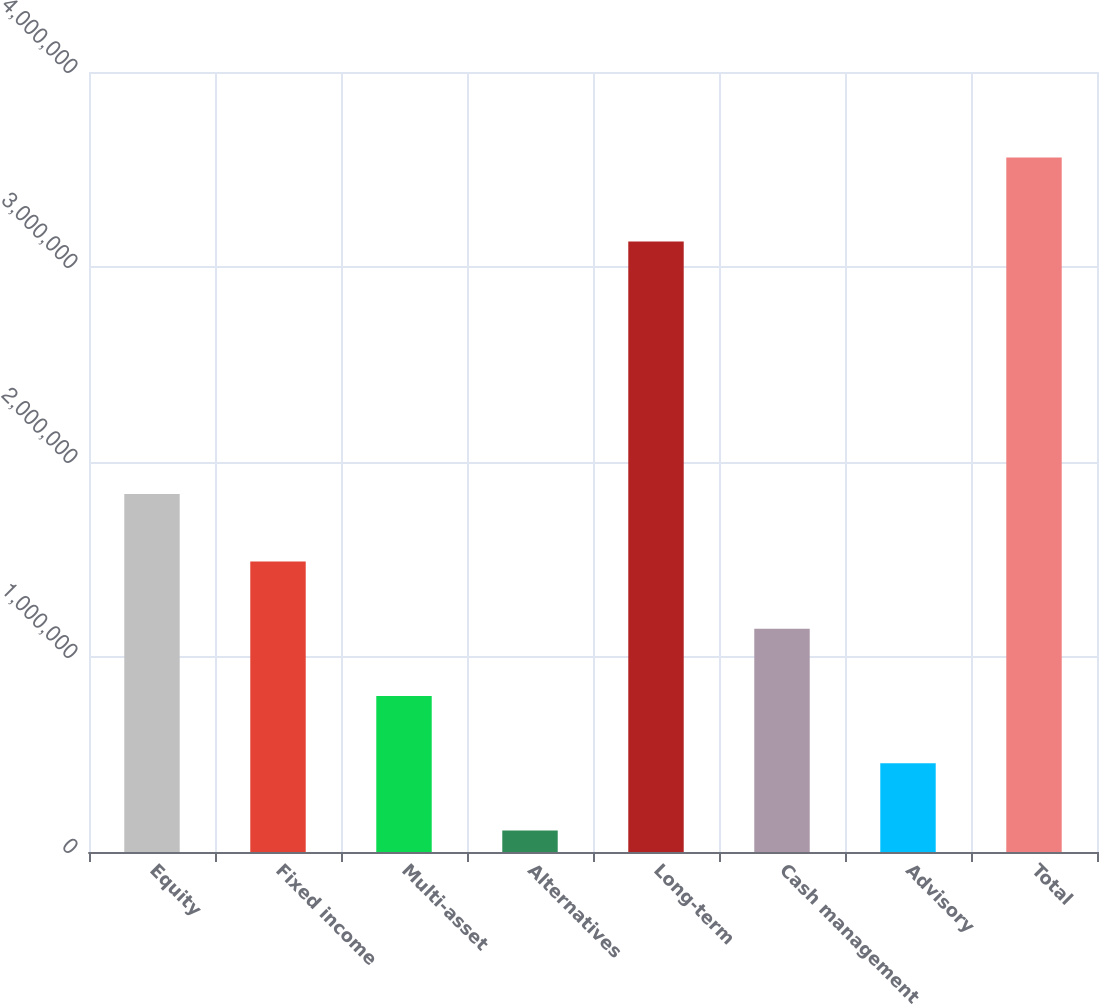Convert chart to OTSL. <chart><loc_0><loc_0><loc_500><loc_500><bar_chart><fcel>Equity<fcel>Fixed income<fcel>Multi-asset<fcel>Alternatives<fcel>Long-term<fcel>Cash management<fcel>Advisory<fcel>Total<nl><fcel>1.83535e+06<fcel>1.49023e+06<fcel>799984<fcel>109738<fcel>3.13112e+06<fcel>1.14511e+06<fcel>454861<fcel>3.56097e+06<nl></chart> 